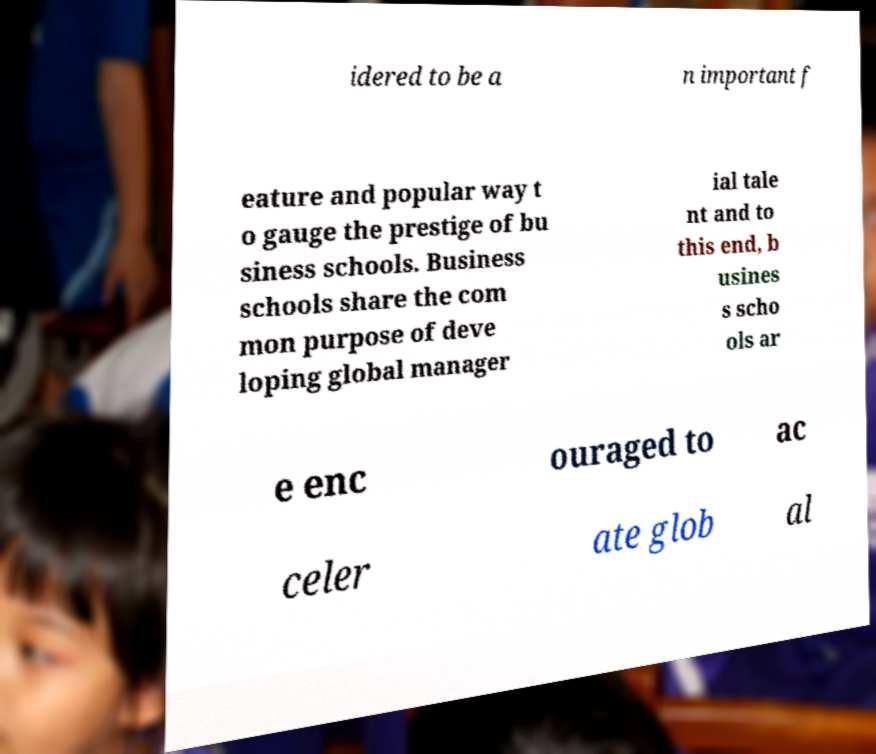Could you extract and type out the text from this image? idered to be a n important f eature and popular way t o gauge the prestige of bu siness schools. Business schools share the com mon purpose of deve loping global manager ial tale nt and to this end, b usines s scho ols ar e enc ouraged to ac celer ate glob al 